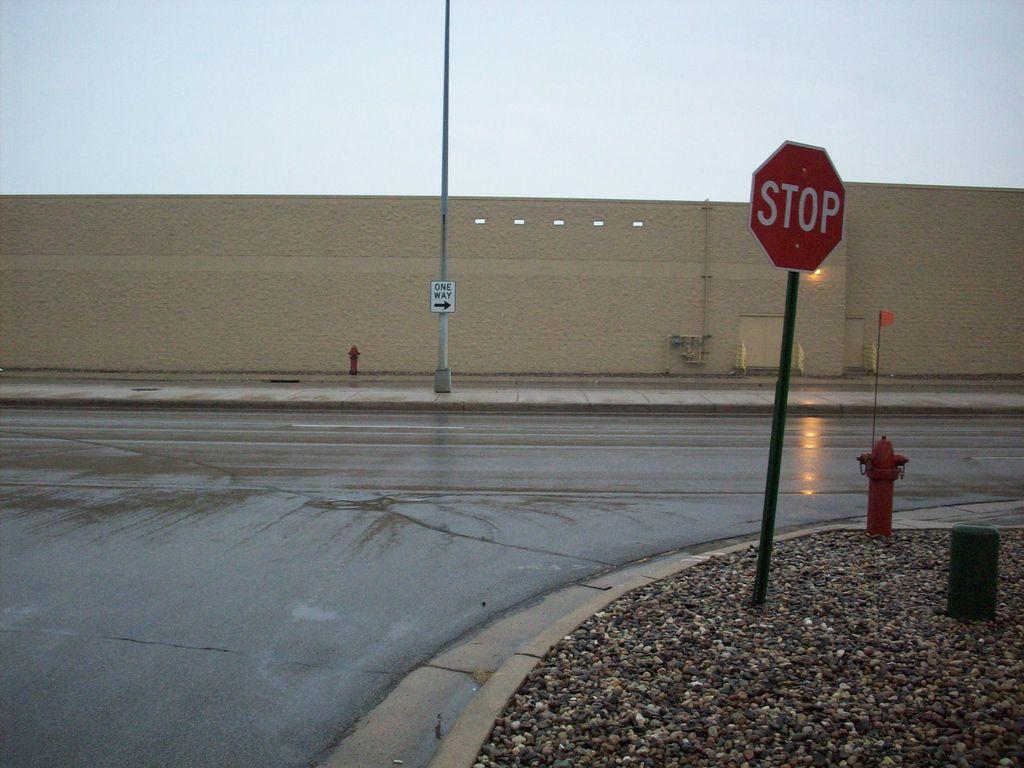What word is on the red sign?
Your response must be concise. Stop. What does the white sign say in the back?
Your answer should be compact. One way. 